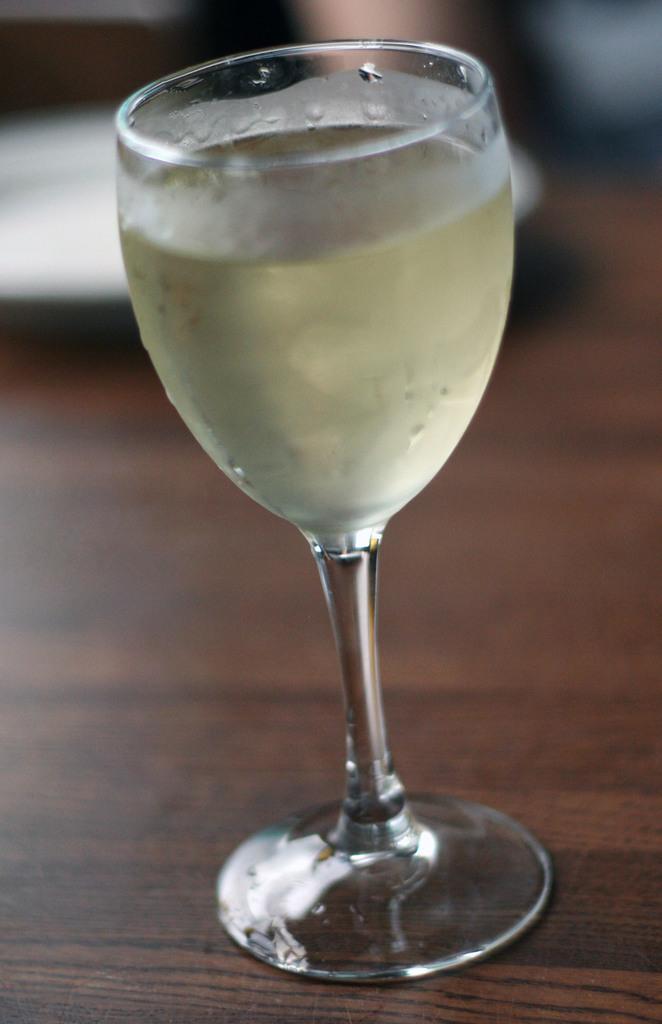In one or two sentences, can you explain what this image depicts? In this image I can see a glass and some liquid in it. The glass is on the table and the table is in brown color. 